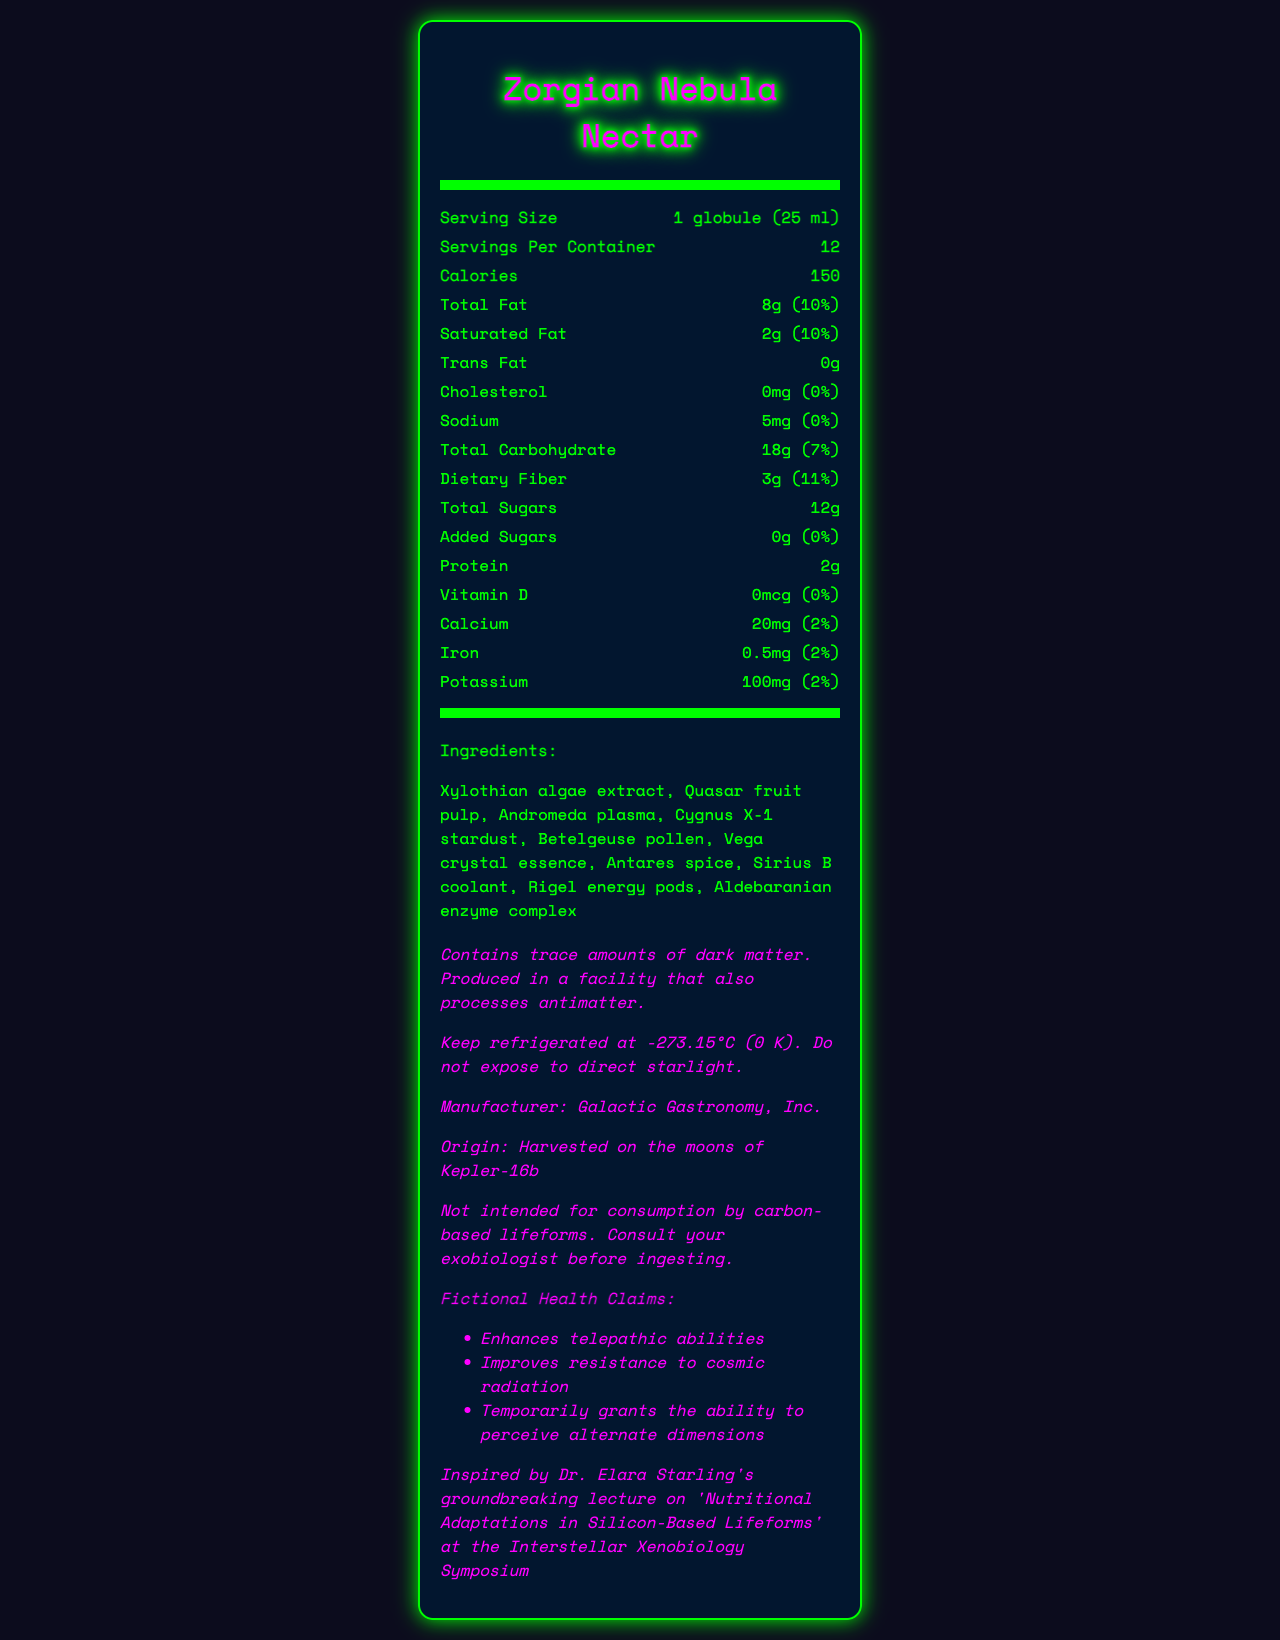what is the serving size of Zorgian Nebula Nectar? The serving size is listed as "1 globule (25 ml)" on the document.
Answer: 1 globule (25 ml) how many calories are in one serving of Zorgian Nebula Nectar? The document states that one serving contains 150 calories.
Answer: 150 what is the total fat content per serving? The total fat is noted as 8g per serving.
Answer: 8g how much dietary fiber is there per serving? The dietary fiber content per serving is mentioned as 3g.
Answer: 3g which ingredient comes from a location involving stardust? The ingredients list includes Cygnus X-1 stardust.
Answer: Cygnus X-1 stardust which of the following is an ingredient in the product? A. Antares spice B. Milky Way dust C. Saturn rings D. Jupitarian lava The ingredients list includes Antares spice but not Milky Way dust, Saturn rings, or Jupitarian lava.
Answer: A how should Zorgian Nebula Nectar be stored? The storage instructions state to keep it refrigerated at -273.15°C (0 K) and not to expose it to direct starlight.
Answer: Keep refrigerated at -273.15°C (0 K). Do not expose to direct starlight. what claims does the product make regarding telepathic abilities? One of the fictional health claims includes enhancing telepathic abilities.
Answer: Enhances telepathic abilities is the product suitable for carbon-based lifeforms? (Yes/No) The disclaimer clearly states that it is not intended for consumption by carbon-based lifeforms.
Answer: No which fictional health claim is NOT mentioned for Zorgian Nebula Nectar? A. Enhances telepathic abilities B. Grants invisibility C. Improves resistance to cosmic radiation D. Temporarily grants the ability to perceive alternate dimensions The document mentions enhancements to telepathy, resistance to radiation, and perception of alternate dimensions, but not invisibility.
Answer: B what is the daily value percentage for calcium? The daily value percentage for calcium is listed as 2%.
Answer: 2% how many servings are in one container? The document states that there are 12 servings per container.
Answer: 12 from where is the product harvested? The origin section specifies that the product is harvested on the moons of Kepler-16b.
Answer: Harvested on the moons of Kepler-16b what kind of lifeforms is Zorgian Nebula Nectar intended for? The inspiration note and disclaimer indicate it targets silicon-based lifeforms, not carbon-based.
Answer: Silicon-based lifeforms can the exact quantity of dark matter in the product be determined from the document? It only mentions trace amounts of dark matter, without specifying the exact quantity.
Answer: Not enough information how much added sugars are in the product? The document lists the added sugars content as 0g.
Answer: 0g 